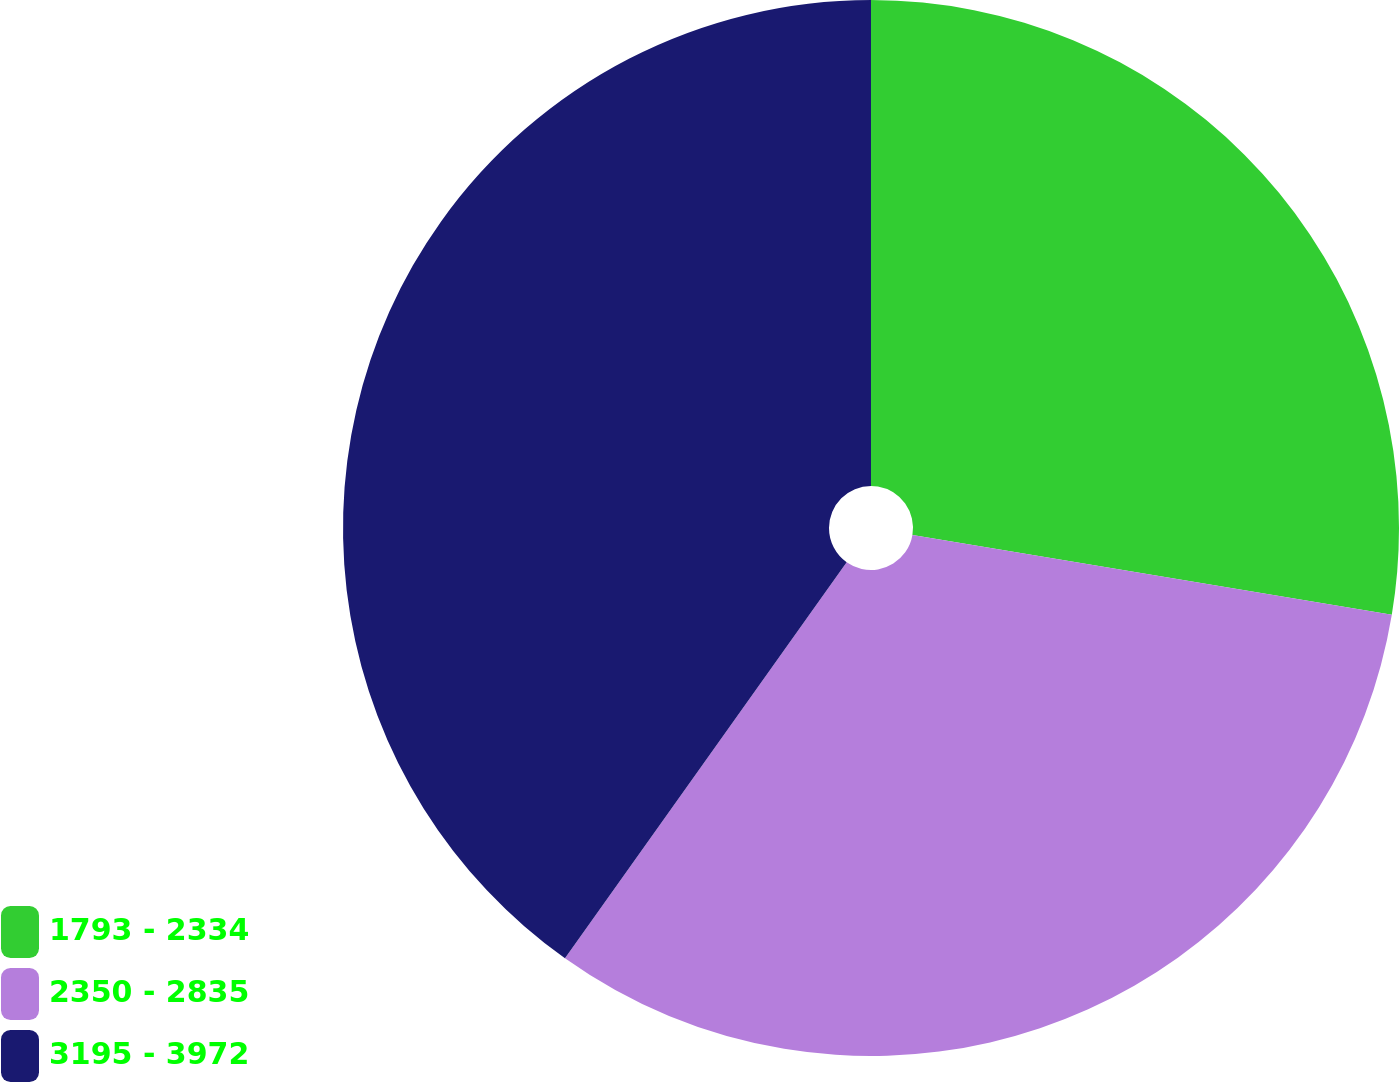<chart> <loc_0><loc_0><loc_500><loc_500><pie_chart><fcel>1793 - 2334<fcel>2350 - 2835<fcel>3195 - 3972<nl><fcel>27.63%<fcel>32.21%<fcel>40.16%<nl></chart> 